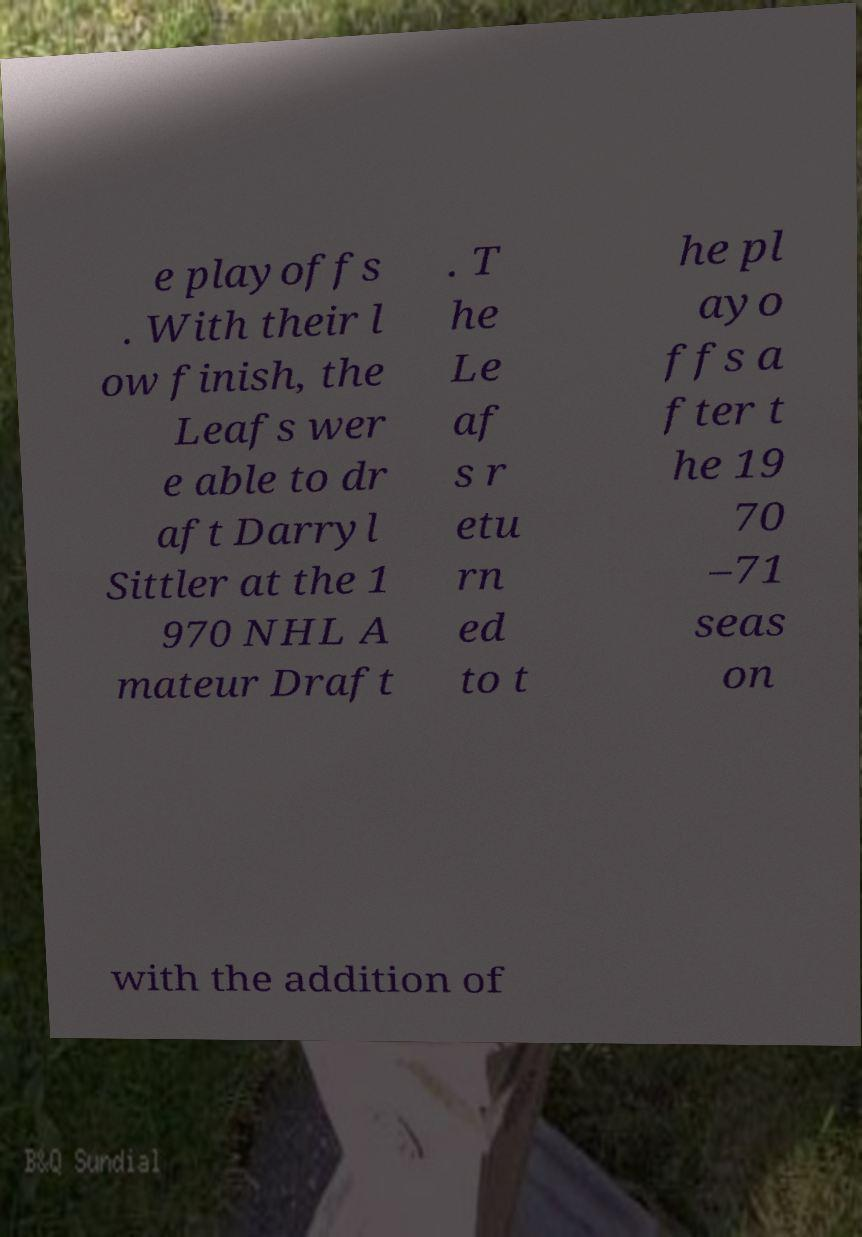Can you accurately transcribe the text from the provided image for me? e playoffs . With their l ow finish, the Leafs wer e able to dr aft Darryl Sittler at the 1 970 NHL A mateur Draft . T he Le af s r etu rn ed to t he pl ayo ffs a fter t he 19 70 –71 seas on with the addition of 